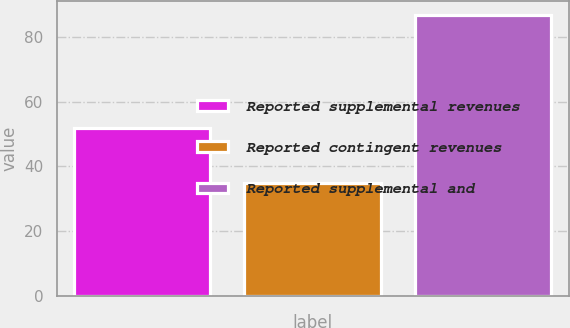Convert chart. <chart><loc_0><loc_0><loc_500><loc_500><bar_chart><fcel>Reported supplemental revenues<fcel>Reported contingent revenues<fcel>Reported supplemental and<nl><fcel>52<fcel>34.9<fcel>86.9<nl></chart> 